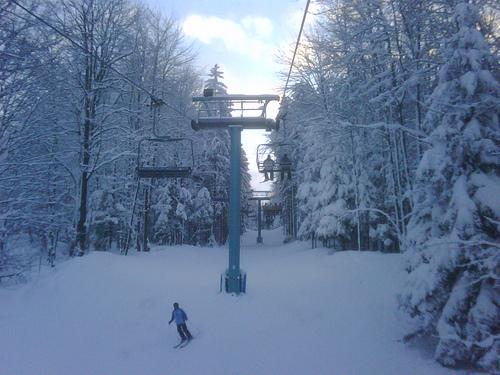How many people in the ski lift?
Short answer required. 2. Is anyone skiing?
Short answer required. Yes. Is there snow?
Quick response, please. Yes. What is the angle of slope of the roof in the background?
Quick response, please. No roof. Is the skier on the ski lift?
Be succinct. Yes. 